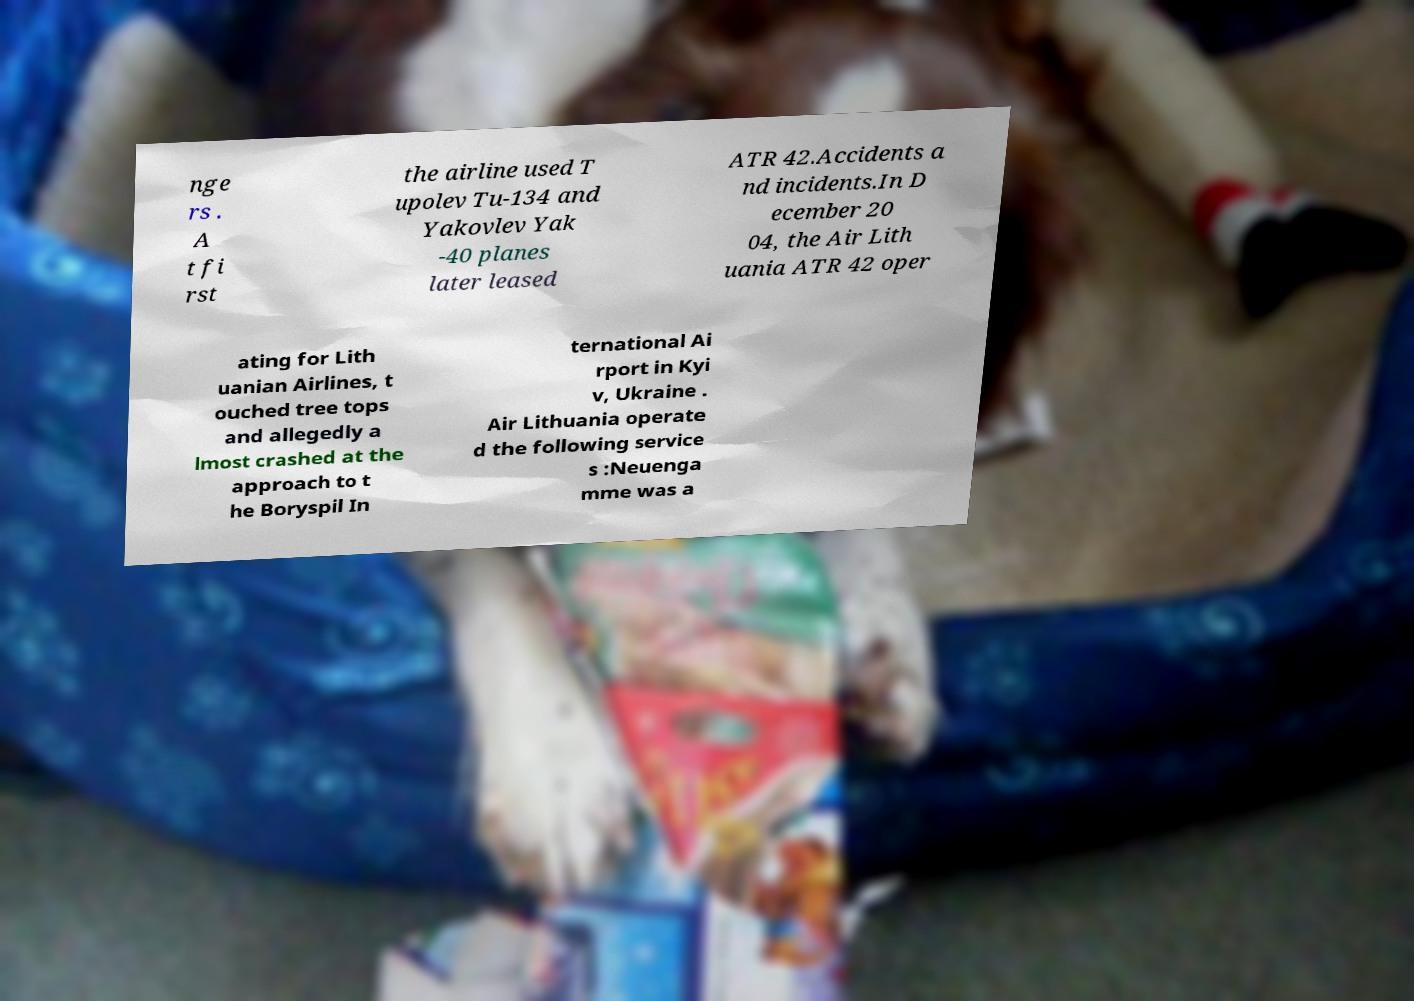Could you extract and type out the text from this image? nge rs . A t fi rst the airline used T upolev Tu-134 and Yakovlev Yak -40 planes later leased ATR 42.Accidents a nd incidents.In D ecember 20 04, the Air Lith uania ATR 42 oper ating for Lith uanian Airlines, t ouched tree tops and allegedly a lmost crashed at the approach to t he Boryspil In ternational Ai rport in Kyi v, Ukraine . Air Lithuania operate d the following service s :Neuenga mme was a 